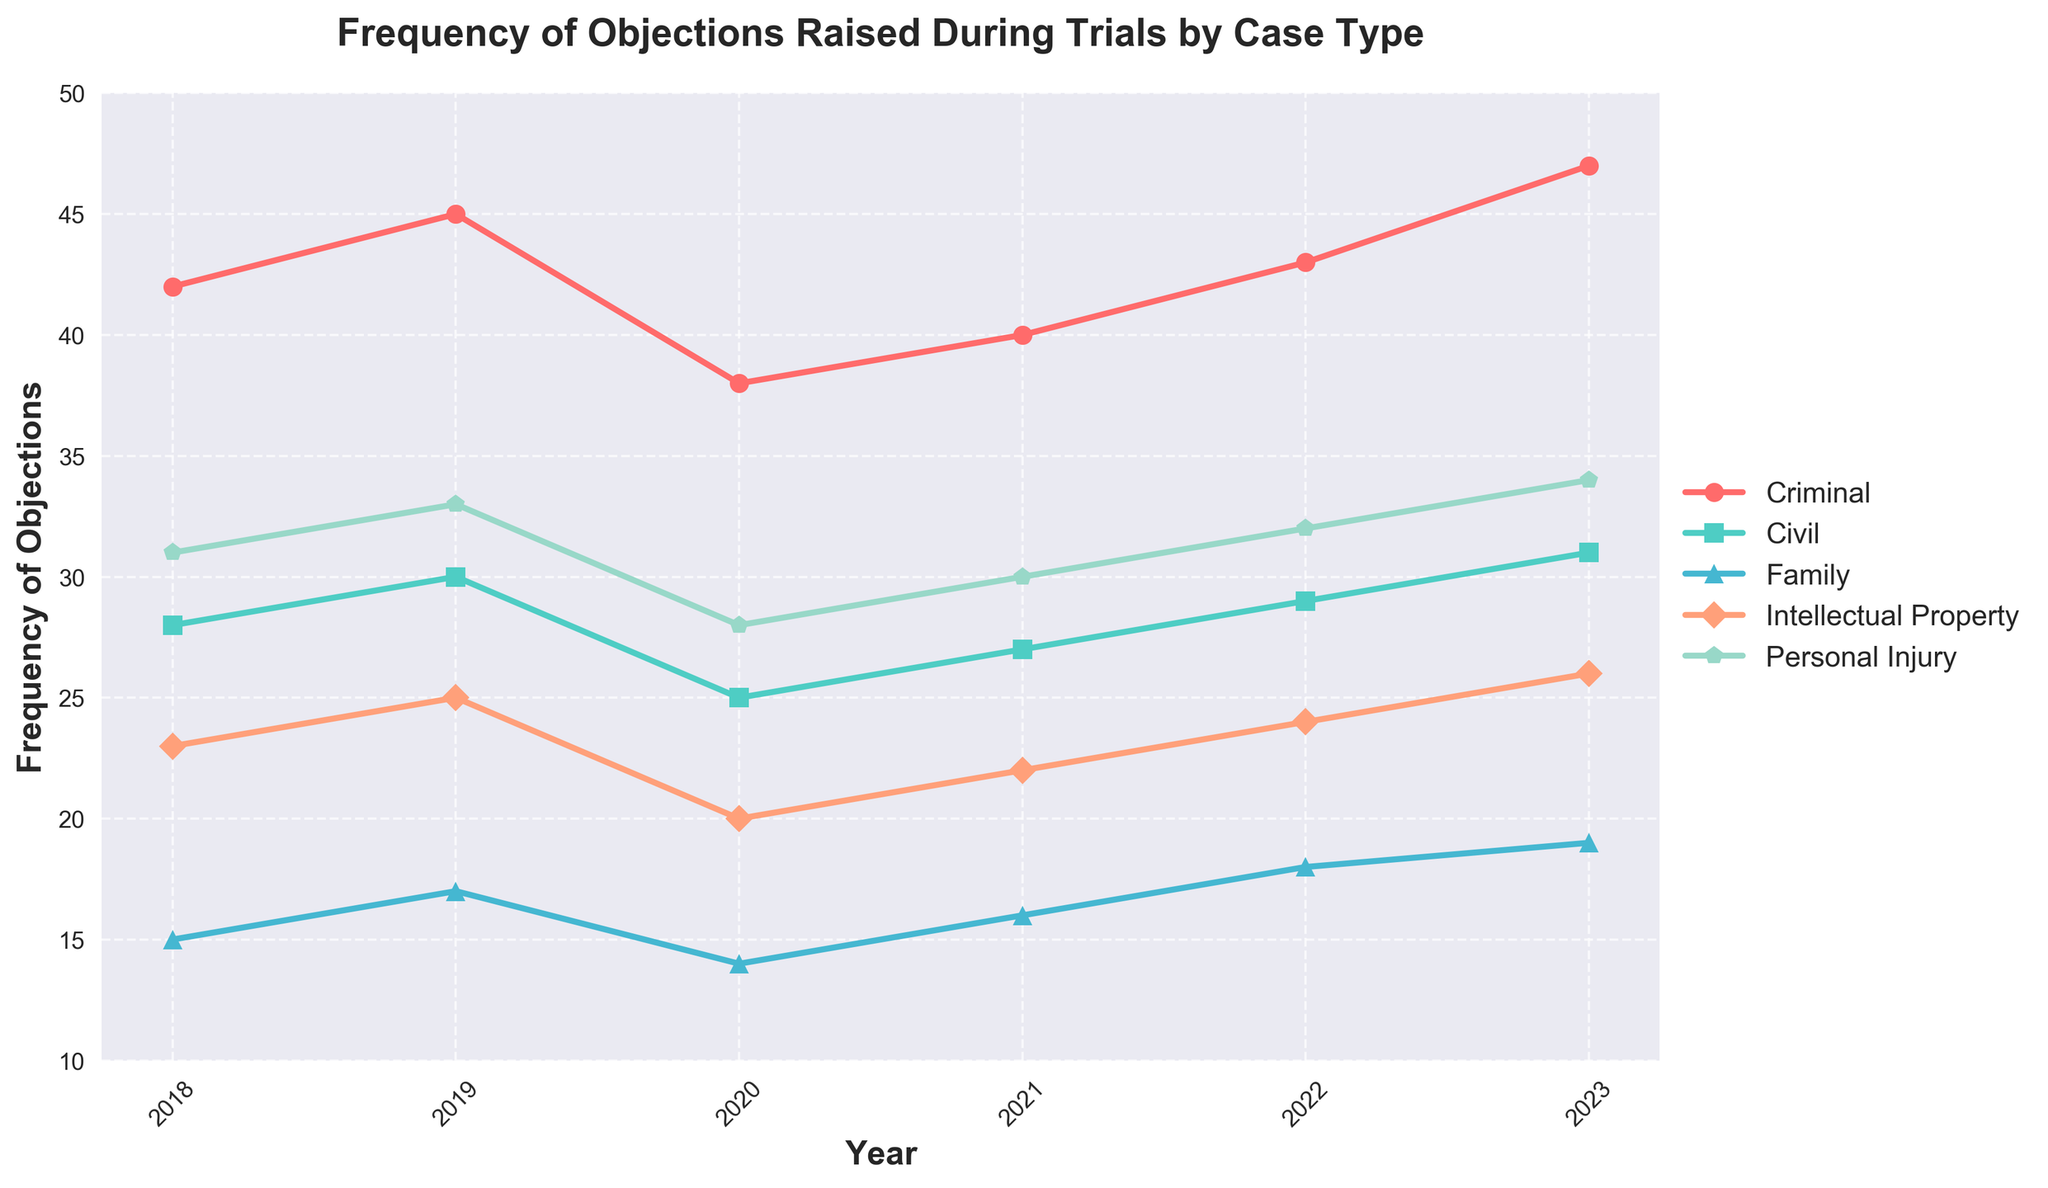What year had the highest frequency of objections in criminal cases? The 'Criminal' line on the plot shows the highest point in 2023.
Answer: 2023 How does the frequency of objections in civil cases compare between 2018 and 2022? Referring to the 'Civil' line on the plot, the frequency in 2018 is 28, and in 2022 it is 29. Since 29 is greater than 28, the frequency has increased.
Answer: Increased What is the average frequency of objections in intellectual property cases over the years? Summing the frequencies of 'Intellectual Property' from 2018 to 2023 (23 + 25 + 20 + 22 + 24 + 26) equals 140. Dividing by 6 gives an average of 23.33.
Answer: 23.33 Which case type had the lowest frequency of objections in 2020? The 2020 values for each case type are checked: Criminal (38), Civil (25), Family (14), Intellectual Property (20), Personal Injury (28). The smallest value is 14 for 'Family'.
Answer: Family In which year did personal injury cases see the maximum frequency of objections? The 'Personal Injury' line shows the highest value is 34, which occurs in 2023.
Answer: 2023 Comparing family cases and intellectual property cases, which had more objections in 2021? In 2021, the frequency for 'Family' cases is 16 and for 'Intellectual Property' cases is 22. Since 22 is greater than 16, intellectual property cases had more objections.
Answer: Intellectual Property What is the total number of objections for civil cases from 2018 to 2023? Adding the frequencies from the 'Civil' line: 28 + 30 + 25 + 27 + 29 + 31 equals 170.
Answer: 170 If you sum the objections for all case types in 2019, what is the total? Summing all case types for 2019: 45 (Criminal) + 30 (Civil) + 17 (Family) + 25 (Intellectual Property) + 33 (Personal Injury) equals 150.
Answer: 150 Did the objections in family cases increase or decrease from 2020 to 2023? The 'Family' line shows values of 14 in 2020 and 19 in 2023. Since 19 is greater than 14, the objections increased.
Answer: Increased 